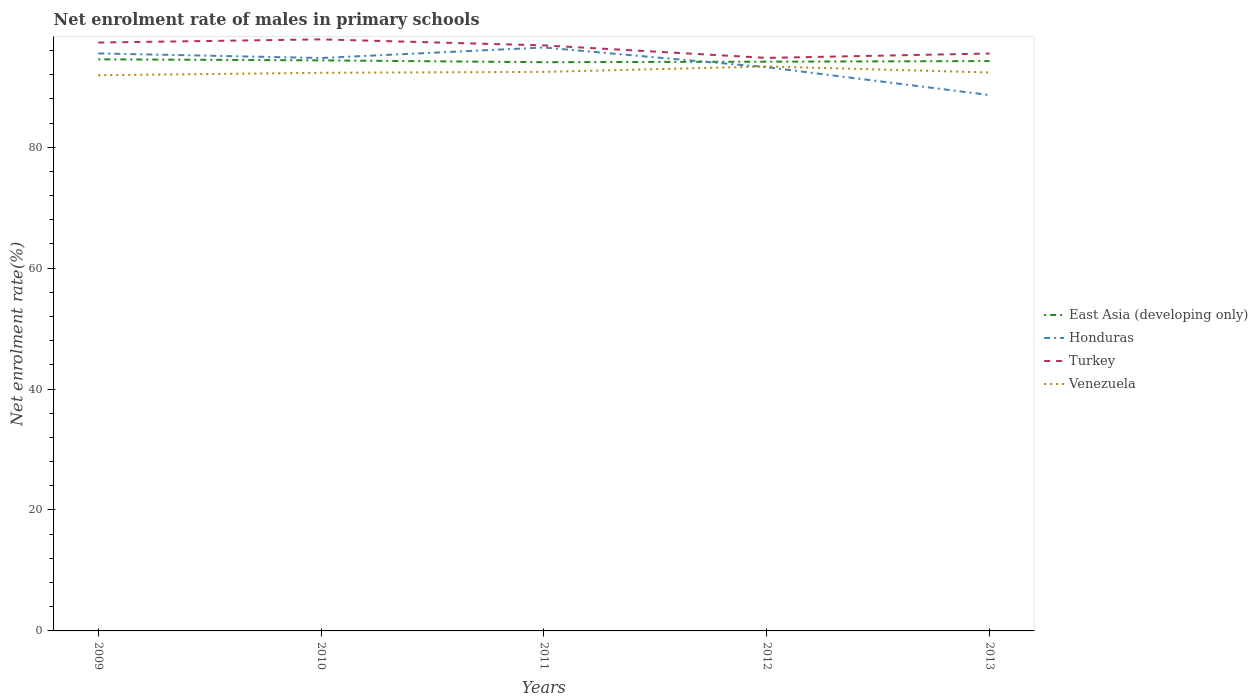Is the number of lines equal to the number of legend labels?
Make the answer very short. Yes. Across all years, what is the maximum net enrolment rate of males in primary schools in Honduras?
Provide a short and direct response. 88.63. In which year was the net enrolment rate of males in primary schools in Venezuela maximum?
Make the answer very short. 2009. What is the total net enrolment rate of males in primary schools in Venezuela in the graph?
Provide a succinct answer. -0.41. What is the difference between the highest and the second highest net enrolment rate of males in primary schools in Venezuela?
Provide a succinct answer. 1.45. How many lines are there?
Ensure brevity in your answer.  4. What is the difference between two consecutive major ticks on the Y-axis?
Give a very brief answer. 20. Does the graph contain grids?
Your answer should be compact. No. How are the legend labels stacked?
Give a very brief answer. Vertical. What is the title of the graph?
Your answer should be compact. Net enrolment rate of males in primary schools. What is the label or title of the X-axis?
Make the answer very short. Years. What is the label or title of the Y-axis?
Offer a terse response. Net enrolment rate(%). What is the Net enrolment rate(%) in East Asia (developing only) in 2009?
Your answer should be compact. 94.54. What is the Net enrolment rate(%) in Honduras in 2009?
Your response must be concise. 95.51. What is the Net enrolment rate(%) in Turkey in 2009?
Offer a very short reply. 97.31. What is the Net enrolment rate(%) of Venezuela in 2009?
Keep it short and to the point. 91.9. What is the Net enrolment rate(%) in East Asia (developing only) in 2010?
Keep it short and to the point. 94.37. What is the Net enrolment rate(%) of Honduras in 2010?
Your answer should be very brief. 94.75. What is the Net enrolment rate(%) of Turkey in 2010?
Your answer should be very brief. 97.84. What is the Net enrolment rate(%) in Venezuela in 2010?
Give a very brief answer. 92.31. What is the Net enrolment rate(%) in East Asia (developing only) in 2011?
Provide a succinct answer. 94.06. What is the Net enrolment rate(%) in Honduras in 2011?
Provide a succinct answer. 96.49. What is the Net enrolment rate(%) in Turkey in 2011?
Your answer should be very brief. 96.84. What is the Net enrolment rate(%) in Venezuela in 2011?
Give a very brief answer. 92.46. What is the Net enrolment rate(%) of East Asia (developing only) in 2012?
Your answer should be compact. 94.15. What is the Net enrolment rate(%) in Honduras in 2012?
Make the answer very short. 93.24. What is the Net enrolment rate(%) in Turkey in 2012?
Offer a very short reply. 94.77. What is the Net enrolment rate(%) in Venezuela in 2012?
Offer a very short reply. 93.36. What is the Net enrolment rate(%) in East Asia (developing only) in 2013?
Keep it short and to the point. 94.25. What is the Net enrolment rate(%) of Honduras in 2013?
Provide a short and direct response. 88.63. What is the Net enrolment rate(%) of Turkey in 2013?
Offer a very short reply. 95.5. What is the Net enrolment rate(%) of Venezuela in 2013?
Your answer should be very brief. 92.36. Across all years, what is the maximum Net enrolment rate(%) in East Asia (developing only)?
Ensure brevity in your answer.  94.54. Across all years, what is the maximum Net enrolment rate(%) of Honduras?
Your response must be concise. 96.49. Across all years, what is the maximum Net enrolment rate(%) in Turkey?
Provide a succinct answer. 97.84. Across all years, what is the maximum Net enrolment rate(%) in Venezuela?
Your answer should be very brief. 93.36. Across all years, what is the minimum Net enrolment rate(%) of East Asia (developing only)?
Your response must be concise. 94.06. Across all years, what is the minimum Net enrolment rate(%) of Honduras?
Make the answer very short. 88.63. Across all years, what is the minimum Net enrolment rate(%) of Turkey?
Make the answer very short. 94.77. Across all years, what is the minimum Net enrolment rate(%) in Venezuela?
Give a very brief answer. 91.9. What is the total Net enrolment rate(%) in East Asia (developing only) in the graph?
Keep it short and to the point. 471.36. What is the total Net enrolment rate(%) of Honduras in the graph?
Provide a succinct answer. 468.63. What is the total Net enrolment rate(%) of Turkey in the graph?
Your answer should be compact. 482.27. What is the total Net enrolment rate(%) in Venezuela in the graph?
Keep it short and to the point. 462.39. What is the difference between the Net enrolment rate(%) of East Asia (developing only) in 2009 and that in 2010?
Provide a short and direct response. 0.17. What is the difference between the Net enrolment rate(%) of Honduras in 2009 and that in 2010?
Your response must be concise. 0.76. What is the difference between the Net enrolment rate(%) in Turkey in 2009 and that in 2010?
Give a very brief answer. -0.53. What is the difference between the Net enrolment rate(%) in Venezuela in 2009 and that in 2010?
Your answer should be compact. -0.41. What is the difference between the Net enrolment rate(%) in East Asia (developing only) in 2009 and that in 2011?
Provide a succinct answer. 0.48. What is the difference between the Net enrolment rate(%) in Honduras in 2009 and that in 2011?
Your response must be concise. -0.98. What is the difference between the Net enrolment rate(%) in Turkey in 2009 and that in 2011?
Offer a very short reply. 0.47. What is the difference between the Net enrolment rate(%) of Venezuela in 2009 and that in 2011?
Your answer should be very brief. -0.56. What is the difference between the Net enrolment rate(%) in East Asia (developing only) in 2009 and that in 2012?
Your response must be concise. 0.39. What is the difference between the Net enrolment rate(%) in Honduras in 2009 and that in 2012?
Your answer should be compact. 2.28. What is the difference between the Net enrolment rate(%) of Turkey in 2009 and that in 2012?
Offer a terse response. 2.54. What is the difference between the Net enrolment rate(%) of Venezuela in 2009 and that in 2012?
Offer a very short reply. -1.45. What is the difference between the Net enrolment rate(%) in East Asia (developing only) in 2009 and that in 2013?
Make the answer very short. 0.29. What is the difference between the Net enrolment rate(%) of Honduras in 2009 and that in 2013?
Offer a terse response. 6.88. What is the difference between the Net enrolment rate(%) in Turkey in 2009 and that in 2013?
Keep it short and to the point. 1.81. What is the difference between the Net enrolment rate(%) of Venezuela in 2009 and that in 2013?
Offer a terse response. -0.46. What is the difference between the Net enrolment rate(%) in East Asia (developing only) in 2010 and that in 2011?
Provide a short and direct response. 0.3. What is the difference between the Net enrolment rate(%) of Honduras in 2010 and that in 2011?
Your response must be concise. -1.74. What is the difference between the Net enrolment rate(%) of Turkey in 2010 and that in 2011?
Ensure brevity in your answer.  1. What is the difference between the Net enrolment rate(%) in Venezuela in 2010 and that in 2011?
Offer a terse response. -0.15. What is the difference between the Net enrolment rate(%) of East Asia (developing only) in 2010 and that in 2012?
Keep it short and to the point. 0.22. What is the difference between the Net enrolment rate(%) in Honduras in 2010 and that in 2012?
Keep it short and to the point. 1.52. What is the difference between the Net enrolment rate(%) of Turkey in 2010 and that in 2012?
Make the answer very short. 3.07. What is the difference between the Net enrolment rate(%) in Venezuela in 2010 and that in 2012?
Your answer should be compact. -1.05. What is the difference between the Net enrolment rate(%) of East Asia (developing only) in 2010 and that in 2013?
Offer a terse response. 0.12. What is the difference between the Net enrolment rate(%) in Honduras in 2010 and that in 2013?
Your answer should be very brief. 6.12. What is the difference between the Net enrolment rate(%) of Turkey in 2010 and that in 2013?
Ensure brevity in your answer.  2.34. What is the difference between the Net enrolment rate(%) of Venezuela in 2010 and that in 2013?
Your answer should be compact. -0.05. What is the difference between the Net enrolment rate(%) of East Asia (developing only) in 2011 and that in 2012?
Your response must be concise. -0.08. What is the difference between the Net enrolment rate(%) in Honduras in 2011 and that in 2012?
Your answer should be compact. 3.26. What is the difference between the Net enrolment rate(%) in Turkey in 2011 and that in 2012?
Your answer should be very brief. 2.07. What is the difference between the Net enrolment rate(%) of Venezuela in 2011 and that in 2012?
Give a very brief answer. -0.9. What is the difference between the Net enrolment rate(%) of East Asia (developing only) in 2011 and that in 2013?
Your answer should be very brief. -0.19. What is the difference between the Net enrolment rate(%) of Honduras in 2011 and that in 2013?
Give a very brief answer. 7.86. What is the difference between the Net enrolment rate(%) in Turkey in 2011 and that in 2013?
Provide a short and direct response. 1.34. What is the difference between the Net enrolment rate(%) of Venezuela in 2011 and that in 2013?
Offer a very short reply. 0.1. What is the difference between the Net enrolment rate(%) in East Asia (developing only) in 2012 and that in 2013?
Offer a terse response. -0.1. What is the difference between the Net enrolment rate(%) in Honduras in 2012 and that in 2013?
Your answer should be compact. 4.61. What is the difference between the Net enrolment rate(%) in Turkey in 2012 and that in 2013?
Offer a terse response. -0.73. What is the difference between the Net enrolment rate(%) in East Asia (developing only) in 2009 and the Net enrolment rate(%) in Honduras in 2010?
Provide a short and direct response. -0.21. What is the difference between the Net enrolment rate(%) in East Asia (developing only) in 2009 and the Net enrolment rate(%) in Turkey in 2010?
Give a very brief answer. -3.3. What is the difference between the Net enrolment rate(%) of East Asia (developing only) in 2009 and the Net enrolment rate(%) of Venezuela in 2010?
Provide a succinct answer. 2.23. What is the difference between the Net enrolment rate(%) in Honduras in 2009 and the Net enrolment rate(%) in Turkey in 2010?
Provide a succinct answer. -2.33. What is the difference between the Net enrolment rate(%) of Honduras in 2009 and the Net enrolment rate(%) of Venezuela in 2010?
Keep it short and to the point. 3.2. What is the difference between the Net enrolment rate(%) in Turkey in 2009 and the Net enrolment rate(%) in Venezuela in 2010?
Provide a succinct answer. 5. What is the difference between the Net enrolment rate(%) of East Asia (developing only) in 2009 and the Net enrolment rate(%) of Honduras in 2011?
Ensure brevity in your answer.  -1.95. What is the difference between the Net enrolment rate(%) of East Asia (developing only) in 2009 and the Net enrolment rate(%) of Turkey in 2011?
Offer a very short reply. -2.3. What is the difference between the Net enrolment rate(%) of East Asia (developing only) in 2009 and the Net enrolment rate(%) of Venezuela in 2011?
Give a very brief answer. 2.08. What is the difference between the Net enrolment rate(%) of Honduras in 2009 and the Net enrolment rate(%) of Turkey in 2011?
Offer a terse response. -1.33. What is the difference between the Net enrolment rate(%) of Honduras in 2009 and the Net enrolment rate(%) of Venezuela in 2011?
Ensure brevity in your answer.  3.05. What is the difference between the Net enrolment rate(%) of Turkey in 2009 and the Net enrolment rate(%) of Venezuela in 2011?
Provide a succinct answer. 4.85. What is the difference between the Net enrolment rate(%) of East Asia (developing only) in 2009 and the Net enrolment rate(%) of Honduras in 2012?
Make the answer very short. 1.3. What is the difference between the Net enrolment rate(%) of East Asia (developing only) in 2009 and the Net enrolment rate(%) of Turkey in 2012?
Your answer should be compact. -0.23. What is the difference between the Net enrolment rate(%) in East Asia (developing only) in 2009 and the Net enrolment rate(%) in Venezuela in 2012?
Give a very brief answer. 1.18. What is the difference between the Net enrolment rate(%) of Honduras in 2009 and the Net enrolment rate(%) of Turkey in 2012?
Ensure brevity in your answer.  0.74. What is the difference between the Net enrolment rate(%) in Honduras in 2009 and the Net enrolment rate(%) in Venezuela in 2012?
Provide a short and direct response. 2.15. What is the difference between the Net enrolment rate(%) of Turkey in 2009 and the Net enrolment rate(%) of Venezuela in 2012?
Your answer should be compact. 3.96. What is the difference between the Net enrolment rate(%) of East Asia (developing only) in 2009 and the Net enrolment rate(%) of Honduras in 2013?
Offer a terse response. 5.91. What is the difference between the Net enrolment rate(%) of East Asia (developing only) in 2009 and the Net enrolment rate(%) of Turkey in 2013?
Offer a terse response. -0.96. What is the difference between the Net enrolment rate(%) of East Asia (developing only) in 2009 and the Net enrolment rate(%) of Venezuela in 2013?
Provide a short and direct response. 2.18. What is the difference between the Net enrolment rate(%) in Honduras in 2009 and the Net enrolment rate(%) in Turkey in 2013?
Keep it short and to the point. 0.01. What is the difference between the Net enrolment rate(%) in Honduras in 2009 and the Net enrolment rate(%) in Venezuela in 2013?
Your response must be concise. 3.15. What is the difference between the Net enrolment rate(%) of Turkey in 2009 and the Net enrolment rate(%) of Venezuela in 2013?
Keep it short and to the point. 4.95. What is the difference between the Net enrolment rate(%) of East Asia (developing only) in 2010 and the Net enrolment rate(%) of Honduras in 2011?
Your answer should be compact. -2.13. What is the difference between the Net enrolment rate(%) of East Asia (developing only) in 2010 and the Net enrolment rate(%) of Turkey in 2011?
Keep it short and to the point. -2.48. What is the difference between the Net enrolment rate(%) of East Asia (developing only) in 2010 and the Net enrolment rate(%) of Venezuela in 2011?
Offer a very short reply. 1.91. What is the difference between the Net enrolment rate(%) of Honduras in 2010 and the Net enrolment rate(%) of Turkey in 2011?
Offer a terse response. -2.09. What is the difference between the Net enrolment rate(%) in Honduras in 2010 and the Net enrolment rate(%) in Venezuela in 2011?
Give a very brief answer. 2.3. What is the difference between the Net enrolment rate(%) in Turkey in 2010 and the Net enrolment rate(%) in Venezuela in 2011?
Provide a short and direct response. 5.38. What is the difference between the Net enrolment rate(%) of East Asia (developing only) in 2010 and the Net enrolment rate(%) of Honduras in 2012?
Give a very brief answer. 1.13. What is the difference between the Net enrolment rate(%) in East Asia (developing only) in 2010 and the Net enrolment rate(%) in Turkey in 2012?
Your answer should be compact. -0.41. What is the difference between the Net enrolment rate(%) in East Asia (developing only) in 2010 and the Net enrolment rate(%) in Venezuela in 2012?
Your answer should be very brief. 1.01. What is the difference between the Net enrolment rate(%) of Honduras in 2010 and the Net enrolment rate(%) of Turkey in 2012?
Give a very brief answer. -0.02. What is the difference between the Net enrolment rate(%) in Honduras in 2010 and the Net enrolment rate(%) in Venezuela in 2012?
Your response must be concise. 1.4. What is the difference between the Net enrolment rate(%) of Turkey in 2010 and the Net enrolment rate(%) of Venezuela in 2012?
Provide a short and direct response. 4.48. What is the difference between the Net enrolment rate(%) of East Asia (developing only) in 2010 and the Net enrolment rate(%) of Honduras in 2013?
Give a very brief answer. 5.74. What is the difference between the Net enrolment rate(%) of East Asia (developing only) in 2010 and the Net enrolment rate(%) of Turkey in 2013?
Your answer should be compact. -1.13. What is the difference between the Net enrolment rate(%) of East Asia (developing only) in 2010 and the Net enrolment rate(%) of Venezuela in 2013?
Give a very brief answer. 2. What is the difference between the Net enrolment rate(%) in Honduras in 2010 and the Net enrolment rate(%) in Turkey in 2013?
Offer a terse response. -0.74. What is the difference between the Net enrolment rate(%) of Honduras in 2010 and the Net enrolment rate(%) of Venezuela in 2013?
Your answer should be compact. 2.39. What is the difference between the Net enrolment rate(%) of Turkey in 2010 and the Net enrolment rate(%) of Venezuela in 2013?
Keep it short and to the point. 5.47. What is the difference between the Net enrolment rate(%) in East Asia (developing only) in 2011 and the Net enrolment rate(%) in Honduras in 2012?
Your response must be concise. 0.83. What is the difference between the Net enrolment rate(%) of East Asia (developing only) in 2011 and the Net enrolment rate(%) of Turkey in 2012?
Provide a succinct answer. -0.71. What is the difference between the Net enrolment rate(%) in East Asia (developing only) in 2011 and the Net enrolment rate(%) in Venezuela in 2012?
Give a very brief answer. 0.7. What is the difference between the Net enrolment rate(%) in Honduras in 2011 and the Net enrolment rate(%) in Turkey in 2012?
Your answer should be compact. 1.72. What is the difference between the Net enrolment rate(%) of Honduras in 2011 and the Net enrolment rate(%) of Venezuela in 2012?
Make the answer very short. 3.14. What is the difference between the Net enrolment rate(%) in Turkey in 2011 and the Net enrolment rate(%) in Venezuela in 2012?
Give a very brief answer. 3.48. What is the difference between the Net enrolment rate(%) of East Asia (developing only) in 2011 and the Net enrolment rate(%) of Honduras in 2013?
Make the answer very short. 5.43. What is the difference between the Net enrolment rate(%) of East Asia (developing only) in 2011 and the Net enrolment rate(%) of Turkey in 2013?
Offer a very short reply. -1.44. What is the difference between the Net enrolment rate(%) of East Asia (developing only) in 2011 and the Net enrolment rate(%) of Venezuela in 2013?
Your response must be concise. 1.7. What is the difference between the Net enrolment rate(%) of Honduras in 2011 and the Net enrolment rate(%) of Venezuela in 2013?
Offer a very short reply. 4.13. What is the difference between the Net enrolment rate(%) in Turkey in 2011 and the Net enrolment rate(%) in Venezuela in 2013?
Your answer should be compact. 4.48. What is the difference between the Net enrolment rate(%) of East Asia (developing only) in 2012 and the Net enrolment rate(%) of Honduras in 2013?
Give a very brief answer. 5.52. What is the difference between the Net enrolment rate(%) of East Asia (developing only) in 2012 and the Net enrolment rate(%) of Turkey in 2013?
Keep it short and to the point. -1.35. What is the difference between the Net enrolment rate(%) of East Asia (developing only) in 2012 and the Net enrolment rate(%) of Venezuela in 2013?
Your answer should be compact. 1.78. What is the difference between the Net enrolment rate(%) in Honduras in 2012 and the Net enrolment rate(%) in Turkey in 2013?
Your answer should be very brief. -2.26. What is the difference between the Net enrolment rate(%) in Honduras in 2012 and the Net enrolment rate(%) in Venezuela in 2013?
Offer a very short reply. 0.87. What is the difference between the Net enrolment rate(%) in Turkey in 2012 and the Net enrolment rate(%) in Venezuela in 2013?
Give a very brief answer. 2.41. What is the average Net enrolment rate(%) in East Asia (developing only) per year?
Your answer should be compact. 94.27. What is the average Net enrolment rate(%) in Honduras per year?
Your response must be concise. 93.73. What is the average Net enrolment rate(%) in Turkey per year?
Your response must be concise. 96.45. What is the average Net enrolment rate(%) of Venezuela per year?
Provide a short and direct response. 92.48. In the year 2009, what is the difference between the Net enrolment rate(%) in East Asia (developing only) and Net enrolment rate(%) in Honduras?
Keep it short and to the point. -0.97. In the year 2009, what is the difference between the Net enrolment rate(%) in East Asia (developing only) and Net enrolment rate(%) in Turkey?
Offer a very short reply. -2.77. In the year 2009, what is the difference between the Net enrolment rate(%) of East Asia (developing only) and Net enrolment rate(%) of Venezuela?
Provide a succinct answer. 2.64. In the year 2009, what is the difference between the Net enrolment rate(%) in Honduras and Net enrolment rate(%) in Turkey?
Make the answer very short. -1.8. In the year 2009, what is the difference between the Net enrolment rate(%) of Honduras and Net enrolment rate(%) of Venezuela?
Your answer should be compact. 3.61. In the year 2009, what is the difference between the Net enrolment rate(%) of Turkey and Net enrolment rate(%) of Venezuela?
Make the answer very short. 5.41. In the year 2010, what is the difference between the Net enrolment rate(%) of East Asia (developing only) and Net enrolment rate(%) of Honduras?
Offer a very short reply. -0.39. In the year 2010, what is the difference between the Net enrolment rate(%) in East Asia (developing only) and Net enrolment rate(%) in Turkey?
Make the answer very short. -3.47. In the year 2010, what is the difference between the Net enrolment rate(%) in East Asia (developing only) and Net enrolment rate(%) in Venezuela?
Provide a short and direct response. 2.06. In the year 2010, what is the difference between the Net enrolment rate(%) in Honduras and Net enrolment rate(%) in Turkey?
Keep it short and to the point. -3.08. In the year 2010, what is the difference between the Net enrolment rate(%) in Honduras and Net enrolment rate(%) in Venezuela?
Keep it short and to the point. 2.45. In the year 2010, what is the difference between the Net enrolment rate(%) of Turkey and Net enrolment rate(%) of Venezuela?
Provide a succinct answer. 5.53. In the year 2011, what is the difference between the Net enrolment rate(%) in East Asia (developing only) and Net enrolment rate(%) in Honduras?
Make the answer very short. -2.43. In the year 2011, what is the difference between the Net enrolment rate(%) in East Asia (developing only) and Net enrolment rate(%) in Turkey?
Offer a terse response. -2.78. In the year 2011, what is the difference between the Net enrolment rate(%) of East Asia (developing only) and Net enrolment rate(%) of Venezuela?
Give a very brief answer. 1.6. In the year 2011, what is the difference between the Net enrolment rate(%) of Honduras and Net enrolment rate(%) of Turkey?
Make the answer very short. -0.35. In the year 2011, what is the difference between the Net enrolment rate(%) of Honduras and Net enrolment rate(%) of Venezuela?
Ensure brevity in your answer.  4.04. In the year 2011, what is the difference between the Net enrolment rate(%) in Turkey and Net enrolment rate(%) in Venezuela?
Offer a terse response. 4.38. In the year 2012, what is the difference between the Net enrolment rate(%) of East Asia (developing only) and Net enrolment rate(%) of Honduras?
Your answer should be compact. 0.91. In the year 2012, what is the difference between the Net enrolment rate(%) in East Asia (developing only) and Net enrolment rate(%) in Turkey?
Your answer should be compact. -0.63. In the year 2012, what is the difference between the Net enrolment rate(%) of East Asia (developing only) and Net enrolment rate(%) of Venezuela?
Offer a very short reply. 0.79. In the year 2012, what is the difference between the Net enrolment rate(%) in Honduras and Net enrolment rate(%) in Turkey?
Keep it short and to the point. -1.54. In the year 2012, what is the difference between the Net enrolment rate(%) in Honduras and Net enrolment rate(%) in Venezuela?
Ensure brevity in your answer.  -0.12. In the year 2012, what is the difference between the Net enrolment rate(%) in Turkey and Net enrolment rate(%) in Venezuela?
Provide a succinct answer. 1.41. In the year 2013, what is the difference between the Net enrolment rate(%) of East Asia (developing only) and Net enrolment rate(%) of Honduras?
Keep it short and to the point. 5.62. In the year 2013, what is the difference between the Net enrolment rate(%) in East Asia (developing only) and Net enrolment rate(%) in Turkey?
Ensure brevity in your answer.  -1.25. In the year 2013, what is the difference between the Net enrolment rate(%) in East Asia (developing only) and Net enrolment rate(%) in Venezuela?
Your response must be concise. 1.88. In the year 2013, what is the difference between the Net enrolment rate(%) in Honduras and Net enrolment rate(%) in Turkey?
Provide a succinct answer. -6.87. In the year 2013, what is the difference between the Net enrolment rate(%) in Honduras and Net enrolment rate(%) in Venezuela?
Give a very brief answer. -3.73. In the year 2013, what is the difference between the Net enrolment rate(%) of Turkey and Net enrolment rate(%) of Venezuela?
Give a very brief answer. 3.14. What is the ratio of the Net enrolment rate(%) of East Asia (developing only) in 2009 to that in 2010?
Your answer should be very brief. 1. What is the ratio of the Net enrolment rate(%) of Honduras in 2009 to that in 2010?
Your answer should be compact. 1.01. What is the ratio of the Net enrolment rate(%) in Turkey in 2009 to that in 2010?
Offer a very short reply. 0.99. What is the ratio of the Net enrolment rate(%) of Turkey in 2009 to that in 2011?
Provide a succinct answer. 1. What is the ratio of the Net enrolment rate(%) of East Asia (developing only) in 2009 to that in 2012?
Your answer should be very brief. 1. What is the ratio of the Net enrolment rate(%) in Honduras in 2009 to that in 2012?
Make the answer very short. 1.02. What is the ratio of the Net enrolment rate(%) of Turkey in 2009 to that in 2012?
Your answer should be compact. 1.03. What is the ratio of the Net enrolment rate(%) of Venezuela in 2009 to that in 2012?
Provide a succinct answer. 0.98. What is the ratio of the Net enrolment rate(%) in East Asia (developing only) in 2009 to that in 2013?
Keep it short and to the point. 1. What is the ratio of the Net enrolment rate(%) of Honduras in 2009 to that in 2013?
Provide a short and direct response. 1.08. What is the ratio of the Net enrolment rate(%) in Turkey in 2009 to that in 2013?
Your response must be concise. 1.02. What is the ratio of the Net enrolment rate(%) of Honduras in 2010 to that in 2011?
Ensure brevity in your answer.  0.98. What is the ratio of the Net enrolment rate(%) in Turkey in 2010 to that in 2011?
Your answer should be very brief. 1.01. What is the ratio of the Net enrolment rate(%) of East Asia (developing only) in 2010 to that in 2012?
Give a very brief answer. 1. What is the ratio of the Net enrolment rate(%) in Honduras in 2010 to that in 2012?
Your answer should be compact. 1.02. What is the ratio of the Net enrolment rate(%) in Turkey in 2010 to that in 2012?
Make the answer very short. 1.03. What is the ratio of the Net enrolment rate(%) of Honduras in 2010 to that in 2013?
Provide a succinct answer. 1.07. What is the ratio of the Net enrolment rate(%) in Turkey in 2010 to that in 2013?
Offer a terse response. 1.02. What is the ratio of the Net enrolment rate(%) in Venezuela in 2010 to that in 2013?
Your response must be concise. 1. What is the ratio of the Net enrolment rate(%) in Honduras in 2011 to that in 2012?
Give a very brief answer. 1.03. What is the ratio of the Net enrolment rate(%) in Turkey in 2011 to that in 2012?
Keep it short and to the point. 1.02. What is the ratio of the Net enrolment rate(%) of East Asia (developing only) in 2011 to that in 2013?
Offer a terse response. 1. What is the ratio of the Net enrolment rate(%) in Honduras in 2011 to that in 2013?
Ensure brevity in your answer.  1.09. What is the ratio of the Net enrolment rate(%) in Turkey in 2011 to that in 2013?
Provide a succinct answer. 1.01. What is the ratio of the Net enrolment rate(%) in Honduras in 2012 to that in 2013?
Provide a succinct answer. 1.05. What is the ratio of the Net enrolment rate(%) of Venezuela in 2012 to that in 2013?
Give a very brief answer. 1.01. What is the difference between the highest and the second highest Net enrolment rate(%) in East Asia (developing only)?
Offer a very short reply. 0.17. What is the difference between the highest and the second highest Net enrolment rate(%) in Honduras?
Make the answer very short. 0.98. What is the difference between the highest and the second highest Net enrolment rate(%) in Turkey?
Offer a terse response. 0.53. What is the difference between the highest and the second highest Net enrolment rate(%) in Venezuela?
Keep it short and to the point. 0.9. What is the difference between the highest and the lowest Net enrolment rate(%) in East Asia (developing only)?
Provide a succinct answer. 0.48. What is the difference between the highest and the lowest Net enrolment rate(%) of Honduras?
Your answer should be very brief. 7.86. What is the difference between the highest and the lowest Net enrolment rate(%) of Turkey?
Ensure brevity in your answer.  3.07. What is the difference between the highest and the lowest Net enrolment rate(%) in Venezuela?
Make the answer very short. 1.45. 